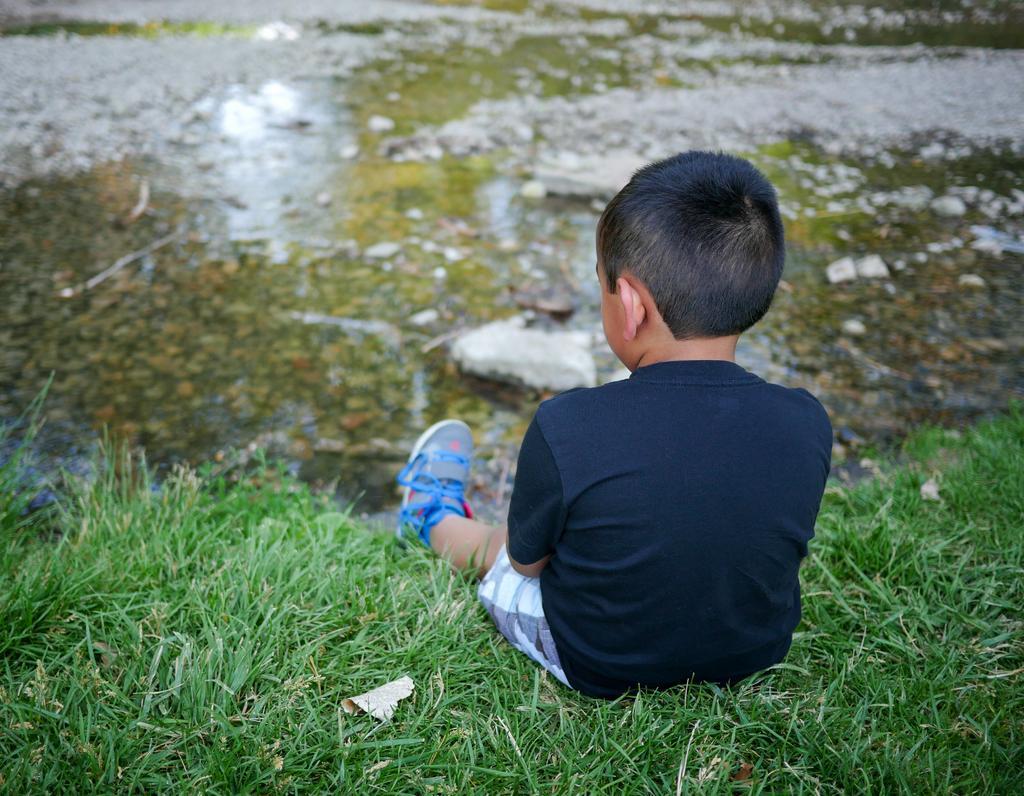Describe this image in one or two sentences. A little boy is sitting on the grass, he wore t-shirt, short, shoes. There is water in the middle of an image. 